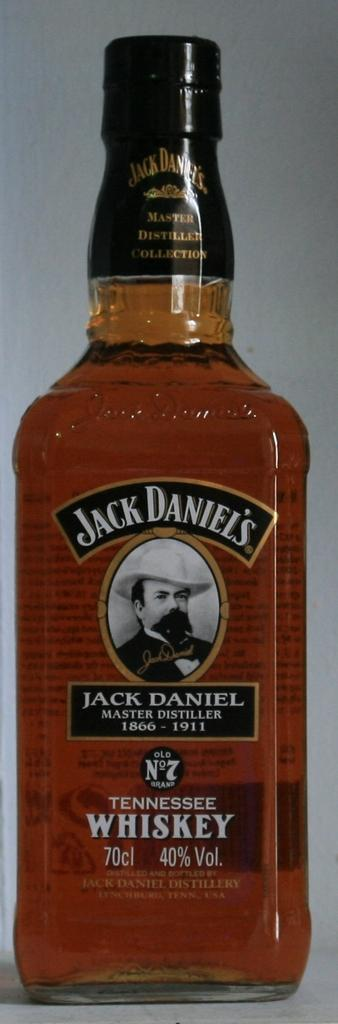<image>
Render a clear and concise summary of the photo. A no 7 Jack Daniel's bottle of whiskey is sitting on the table. 